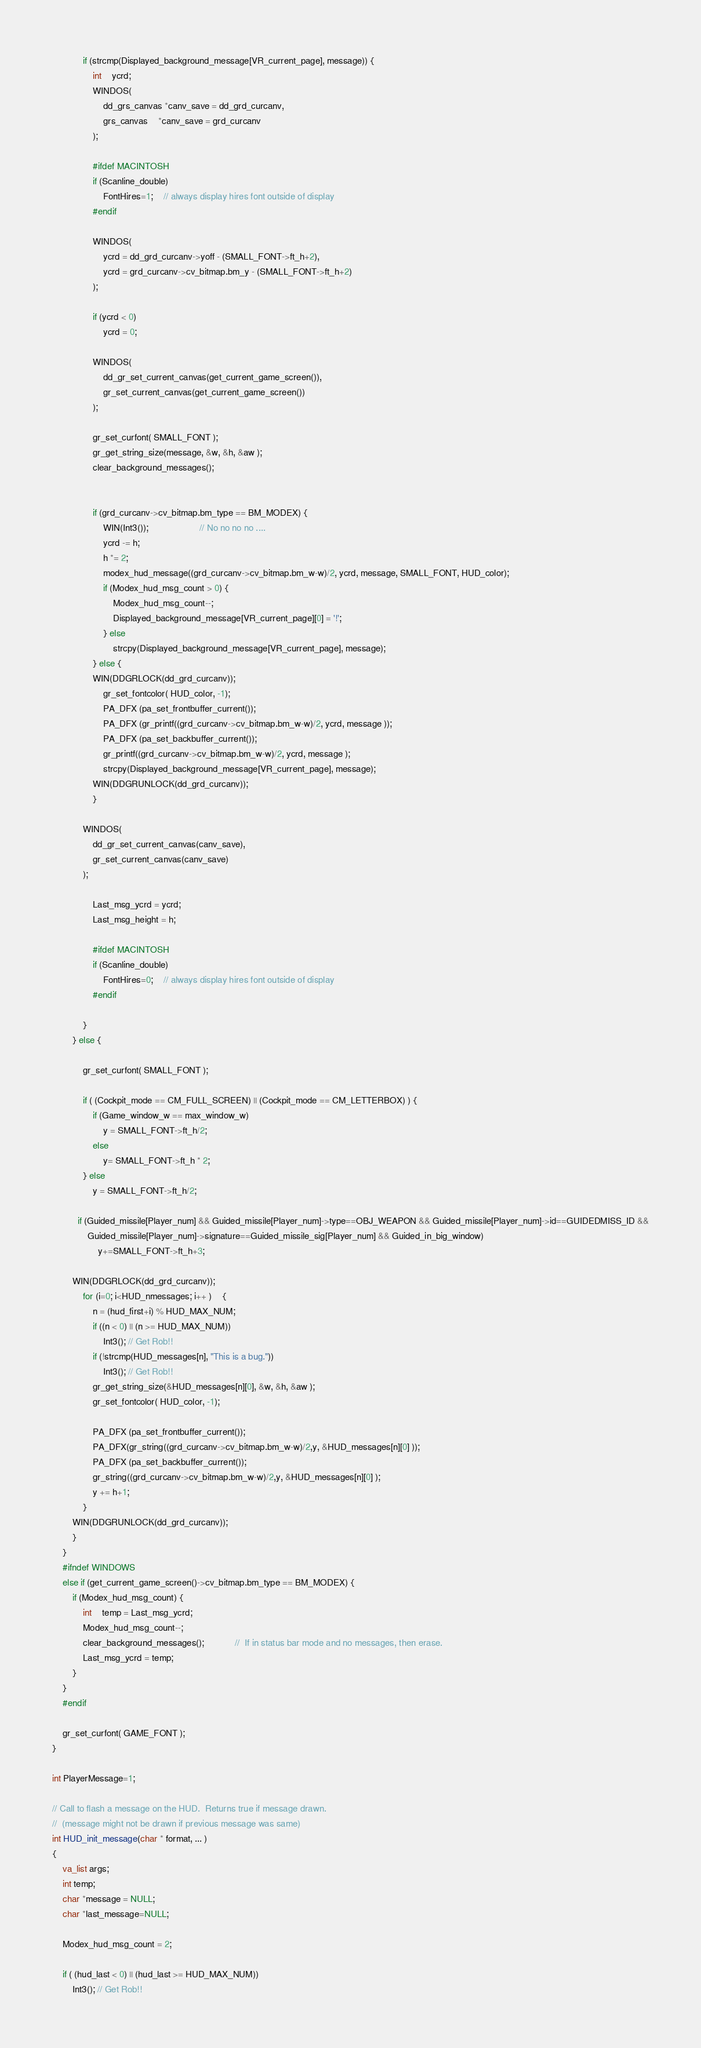Convert code to text. <code><loc_0><loc_0><loc_500><loc_500><_C_>
			if (strcmp(Displayed_background_message[VR_current_page], message)) {
				int	ycrd;
				WINDOS(
					dd_grs_canvas *canv_save = dd_grd_curcanv,
					grs_canvas	*canv_save = grd_curcanv
				);

				#ifdef MACINTOSH
				if (Scanline_double)
					FontHires=1;	// always display hires font outside of display
				#endif

				WINDOS(
					ycrd = dd_grd_curcanv->yoff - (SMALL_FONT->ft_h+2),
					ycrd = grd_curcanv->cv_bitmap.bm_y - (SMALL_FONT->ft_h+2)
				);

				if (ycrd < 0)
					ycrd = 0;

				WINDOS(
					dd_gr_set_current_canvas(get_current_game_screen()),
					gr_set_current_canvas(get_current_game_screen())
				);

				gr_set_curfont( SMALL_FONT );
				gr_get_string_size(message, &w, &h, &aw );
				clear_background_messages();


				if (grd_curcanv->cv_bitmap.bm_type == BM_MODEX) {
					WIN(Int3());					// No no no no ....
					ycrd -= h;
					h *= 2;
					modex_hud_message((grd_curcanv->cv_bitmap.bm_w-w)/2, ycrd, message, SMALL_FONT, HUD_color);
					if (Modex_hud_msg_count > 0) {
						Modex_hud_msg_count--;
						Displayed_background_message[VR_current_page][0] = '!';
					} else
						strcpy(Displayed_background_message[VR_current_page], message);
				} else {
				WIN(DDGRLOCK(dd_grd_curcanv));
					gr_set_fontcolor( HUD_color, -1);
					PA_DFX (pa_set_frontbuffer_current());
					PA_DFX (gr_printf((grd_curcanv->cv_bitmap.bm_w-w)/2, ycrd, message ));
					PA_DFX (pa_set_backbuffer_current());
					gr_printf((grd_curcanv->cv_bitmap.bm_w-w)/2, ycrd, message );
					strcpy(Displayed_background_message[VR_current_page], message);
				WIN(DDGRUNLOCK(dd_grd_curcanv));
				}

			WINDOS(
				dd_gr_set_current_canvas(canv_save),
				gr_set_current_canvas(canv_save)
			);

				Last_msg_ycrd = ycrd;
				Last_msg_height = h;

				#ifdef MACINTOSH
				if (Scanline_double)
					FontHires=0;	// always display hires font outside of display
				#endif

			}
		} else {

			gr_set_curfont( SMALL_FONT );

			if ( (Cockpit_mode == CM_FULL_SCREEN) || (Cockpit_mode == CM_LETTERBOX) ) {
				if (Game_window_w == max_window_w)
					y = SMALL_FONT->ft_h/2;
				else
				 	y= SMALL_FONT->ft_h * 2;
			} else
				y = SMALL_FONT->ft_h/2;

		  if (Guided_missile[Player_num] && Guided_missile[Player_num]->type==OBJ_WEAPON && Guided_missile[Player_num]->id==GUIDEDMISS_ID &&
		      Guided_missile[Player_num]->signature==Guided_missile_sig[Player_num] && Guided_in_big_window)
			      y+=SMALL_FONT->ft_h+3; 

		WIN(DDGRLOCK(dd_grd_curcanv));
		  	for (i=0; i<HUD_nmessages; i++ )	{	
				n = (hud_first+i) % HUD_MAX_NUM;
				if ((n < 0) || (n >= HUD_MAX_NUM))
					Int3(); // Get Rob!!
				if (!strcmp(HUD_messages[n], "This is a bug."))
					Int3(); // Get Rob!!
				gr_get_string_size(&HUD_messages[n][0], &w, &h, &aw );
				gr_set_fontcolor( HUD_color, -1);
			
				PA_DFX (pa_set_frontbuffer_current());
				PA_DFX(gr_string((grd_curcanv->cv_bitmap.bm_w-w)/2,y, &HUD_messages[n][0] ));
				PA_DFX (pa_set_backbuffer_current());
				gr_string((grd_curcanv->cv_bitmap.bm_w-w)/2,y, &HUD_messages[n][0] );
				y += h+1;
			}
		WIN(DDGRUNLOCK(dd_grd_curcanv));
		}
	} 
	#ifndef WINDOWS
	else if (get_current_game_screen()->cv_bitmap.bm_type == BM_MODEX) {
		if (Modex_hud_msg_count) {
			int	temp = Last_msg_ycrd;
			Modex_hud_msg_count--;
			clear_background_messages();			//	If in status bar mode and no messages, then erase.
			Last_msg_ycrd = temp;
		}
	}
	#endif

	gr_set_curfont( GAME_FONT );    
}

int PlayerMessage=1;

// Call to flash a message on the HUD.  Returns true if message drawn.
//  (message might not be drawn if previous message was same)
int HUD_init_message(char * format, ... )
{
	va_list args;
	int temp;
	char *message = NULL;
	char *last_message=NULL;

	Modex_hud_msg_count = 2;

	if ( (hud_last < 0) || (hud_last >= HUD_MAX_NUM))
		Int3(); // Get Rob!!
</code> 